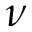Convert formula to latex. <formula><loc_0><loc_0><loc_500><loc_500>\nu</formula> 